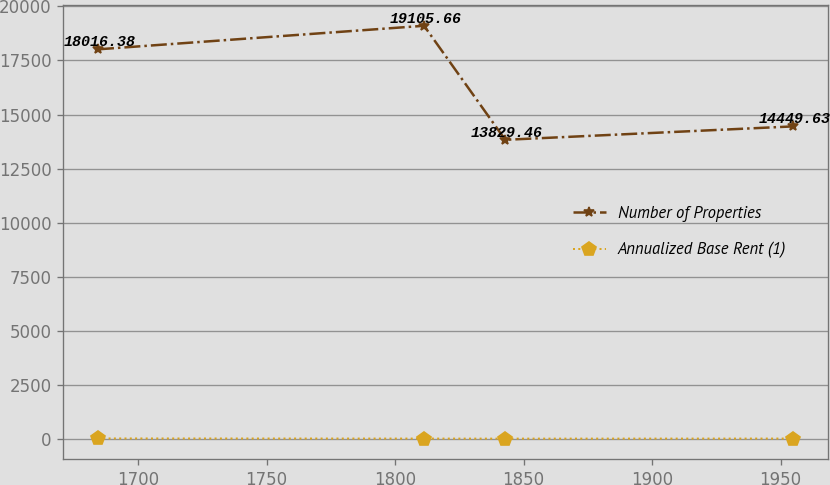Convert chart to OTSL. <chart><loc_0><loc_0><loc_500><loc_500><line_chart><ecel><fcel>Number of Properties<fcel>Annualized Base Rent (1)<nl><fcel>1684.38<fcel>18016.4<fcel>10.3<nl><fcel>1811.28<fcel>19105.7<fcel>4.37<nl><fcel>1842.88<fcel>13829.5<fcel>2<nl><fcel>1954.81<fcel>14449.6<fcel>5.2<nl></chart> 